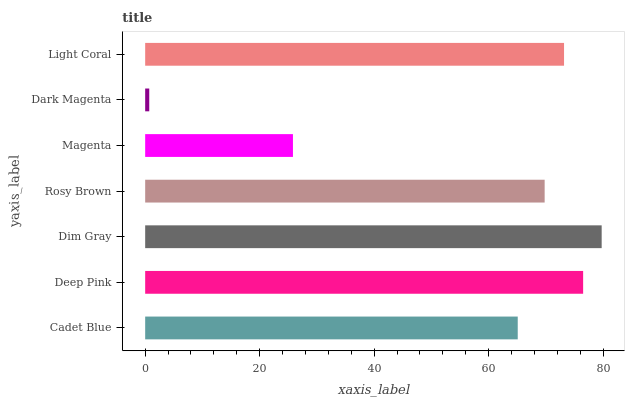Is Dark Magenta the minimum?
Answer yes or no. Yes. Is Dim Gray the maximum?
Answer yes or no. Yes. Is Deep Pink the minimum?
Answer yes or no. No. Is Deep Pink the maximum?
Answer yes or no. No. Is Deep Pink greater than Cadet Blue?
Answer yes or no. Yes. Is Cadet Blue less than Deep Pink?
Answer yes or no. Yes. Is Cadet Blue greater than Deep Pink?
Answer yes or no. No. Is Deep Pink less than Cadet Blue?
Answer yes or no. No. Is Rosy Brown the high median?
Answer yes or no. Yes. Is Rosy Brown the low median?
Answer yes or no. Yes. Is Light Coral the high median?
Answer yes or no. No. Is Cadet Blue the low median?
Answer yes or no. No. 